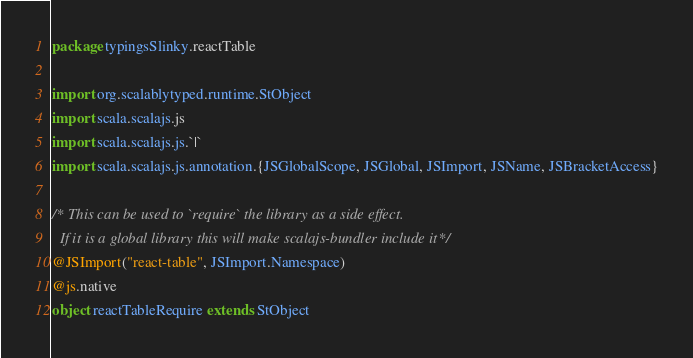Convert code to text. <code><loc_0><loc_0><loc_500><loc_500><_Scala_>package typingsSlinky.reactTable

import org.scalablytyped.runtime.StObject
import scala.scalajs.js
import scala.scalajs.js.`|`
import scala.scalajs.js.annotation.{JSGlobalScope, JSGlobal, JSImport, JSName, JSBracketAccess}

/* This can be used to `require` the library as a side effect.
  If it is a global library this will make scalajs-bundler include it */
@JSImport("react-table", JSImport.Namespace)
@js.native
object reactTableRequire extends StObject
</code> 